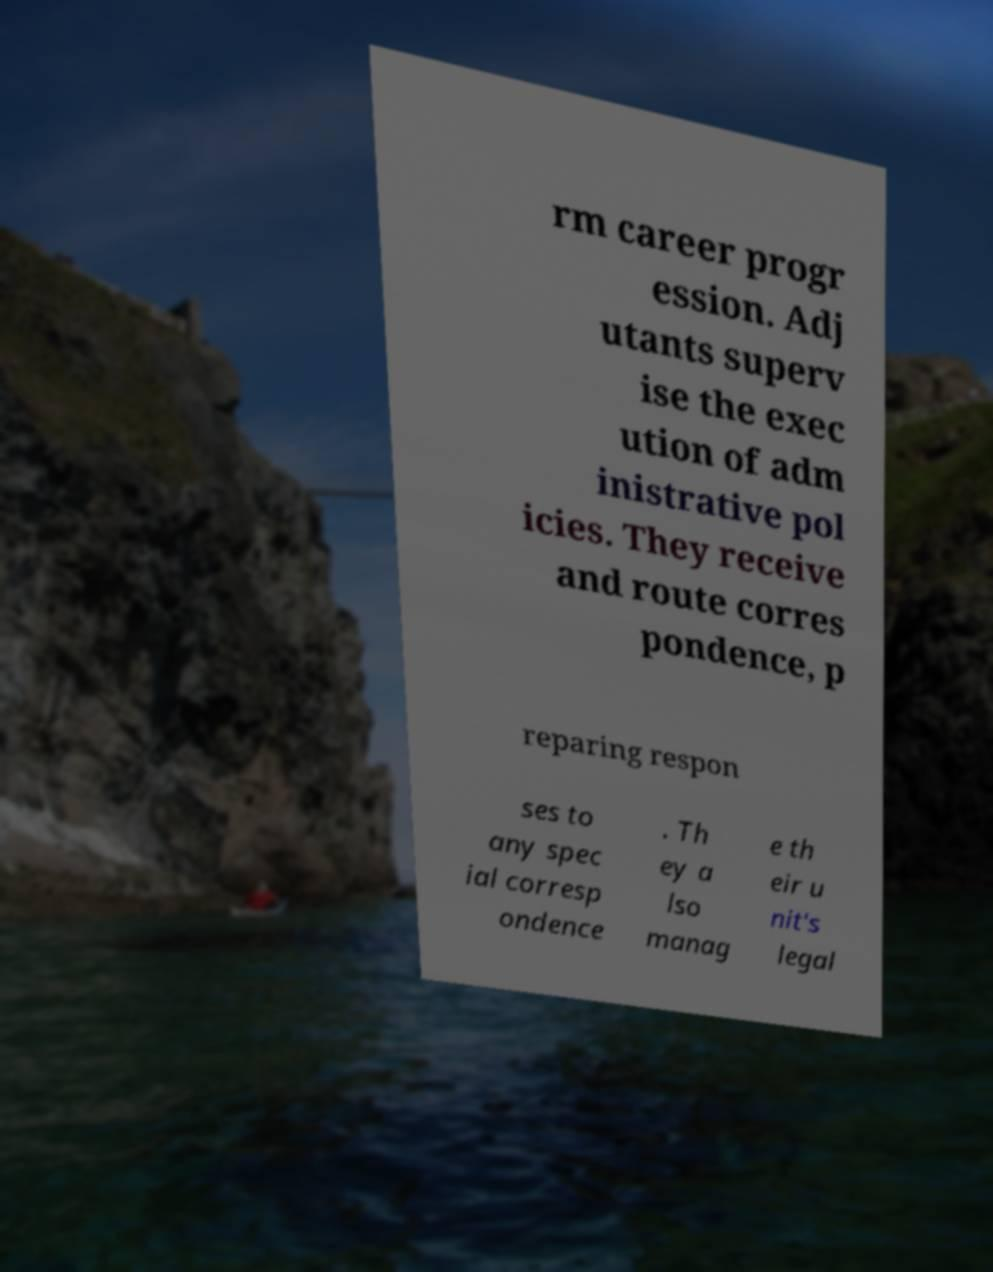Can you accurately transcribe the text from the provided image for me? rm career progr ession. Adj utants superv ise the exec ution of adm inistrative pol icies. They receive and route corres pondence, p reparing respon ses to any spec ial corresp ondence . Th ey a lso manag e th eir u nit's legal 